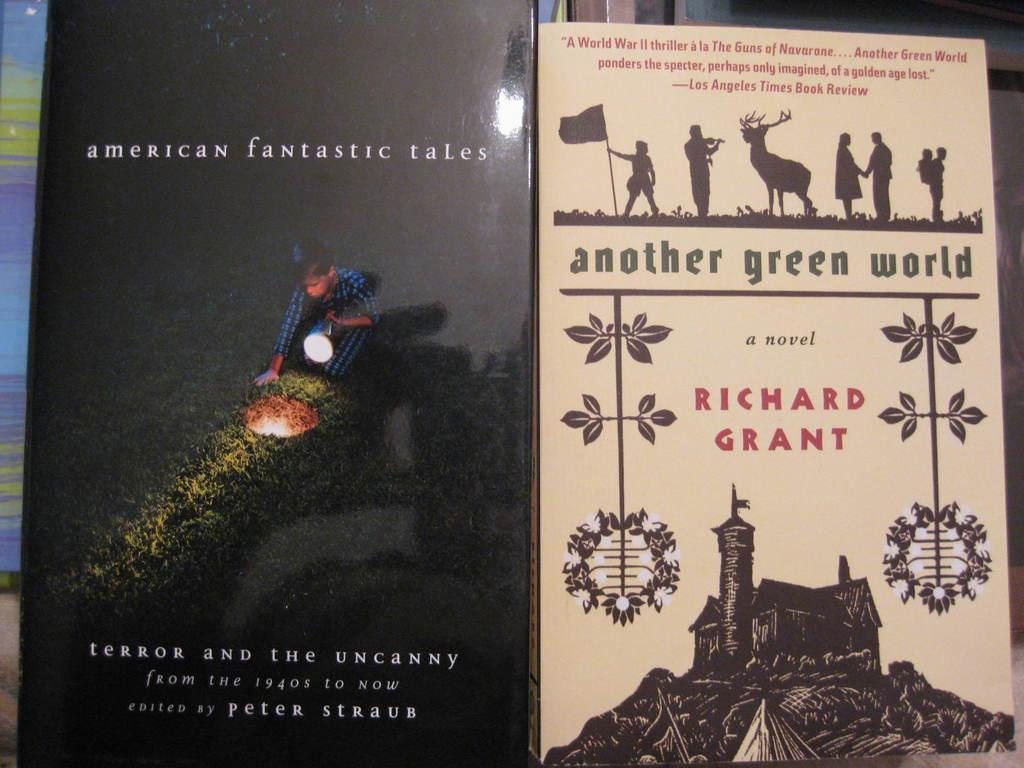Provide a one-sentence caption for the provided image. Two books next to each other, American Fantasy tales and Another Green World. 